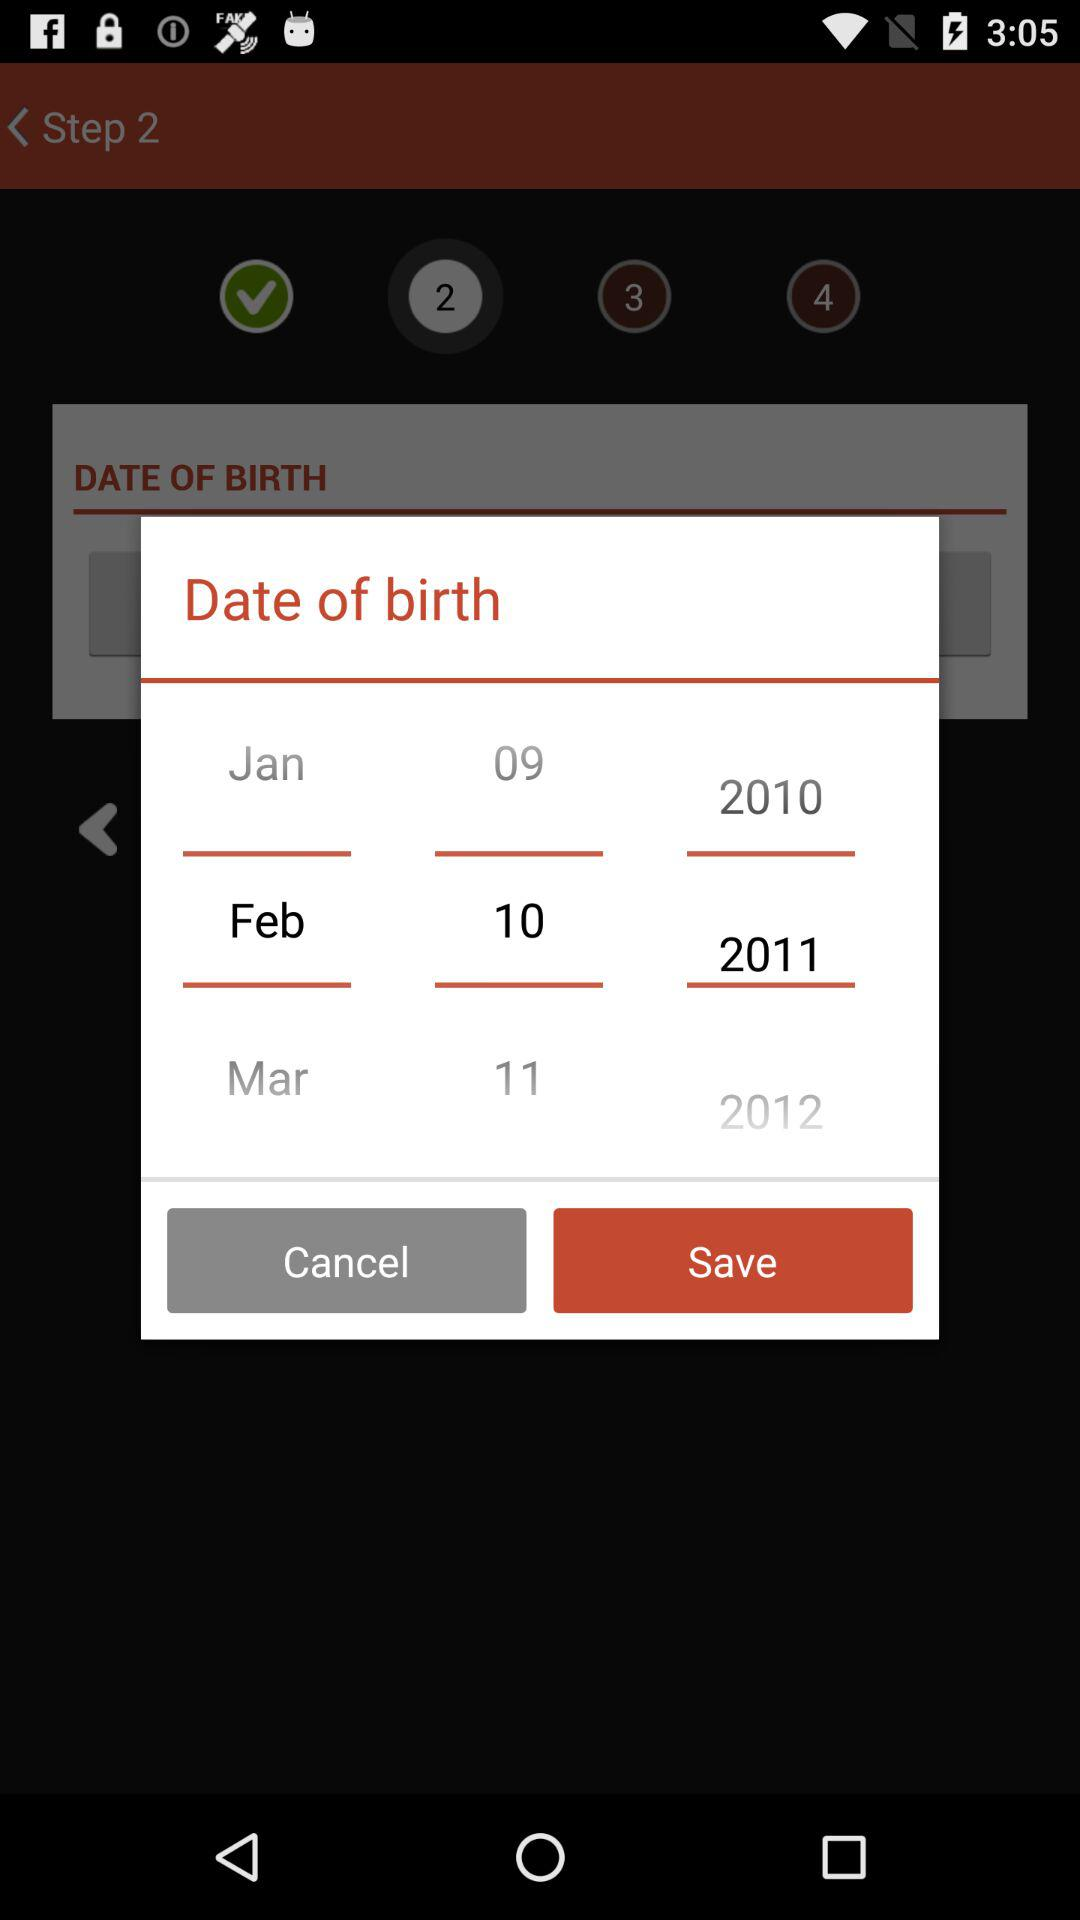How many years are between the oldest and youngest birth dates?
Answer the question using a single word or phrase. 2 